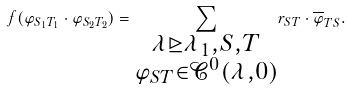<formula> <loc_0><loc_0><loc_500><loc_500>f ( { \varphi } _ { S _ { 1 } T _ { 1 } } \cdot { \varphi } _ { S _ { 2 } T _ { 2 } } ) = \underset { \substack { \lambda \unrhd \lambda _ { 1 } , S , T \\ { \varphi } _ { S T } \in \mathcal { C } ^ { 0 } ( \lambda , 0 ) } } { \sum } r _ { S T } \cdot \overline { \varphi } _ { T S } .</formula> 